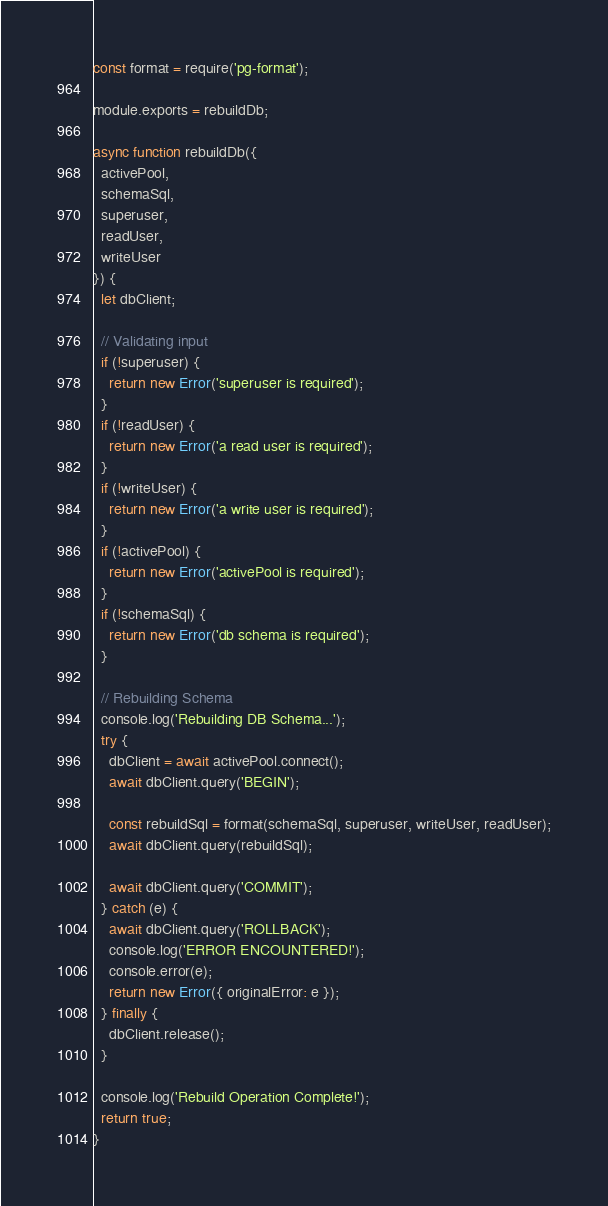Convert code to text. <code><loc_0><loc_0><loc_500><loc_500><_JavaScript_>const format = require('pg-format');

module.exports = rebuildDb;

async function rebuildDb({
  activePool,
  schemaSql,
  superuser,
  readUser,
  writeUser
}) {
  let dbClient;

  // Validating input
  if (!superuser) {
    return new Error('superuser is required');
  }
  if (!readUser) {
    return new Error('a read user is required');
  }
  if (!writeUser) {
    return new Error('a write user is required');
  }
  if (!activePool) {
    return new Error('activePool is required');
  }
  if (!schemaSql) {
    return new Error('db schema is required');
  }

  // Rebuilding Schema
  console.log('Rebuilding DB Schema...');
  try {
    dbClient = await activePool.connect();
    await dbClient.query('BEGIN');

    const rebuildSql = format(schemaSql, superuser, writeUser, readUser);
    await dbClient.query(rebuildSql);

    await dbClient.query('COMMIT');
  } catch (e) {
    await dbClient.query('ROLLBACK');
    console.log('ERROR ENCOUNTERED!');
    console.error(e);
    return new Error({ originalError: e });
  } finally {
    dbClient.release();
  }

  console.log('Rebuild Operation Complete!');
  return true;
}</code> 